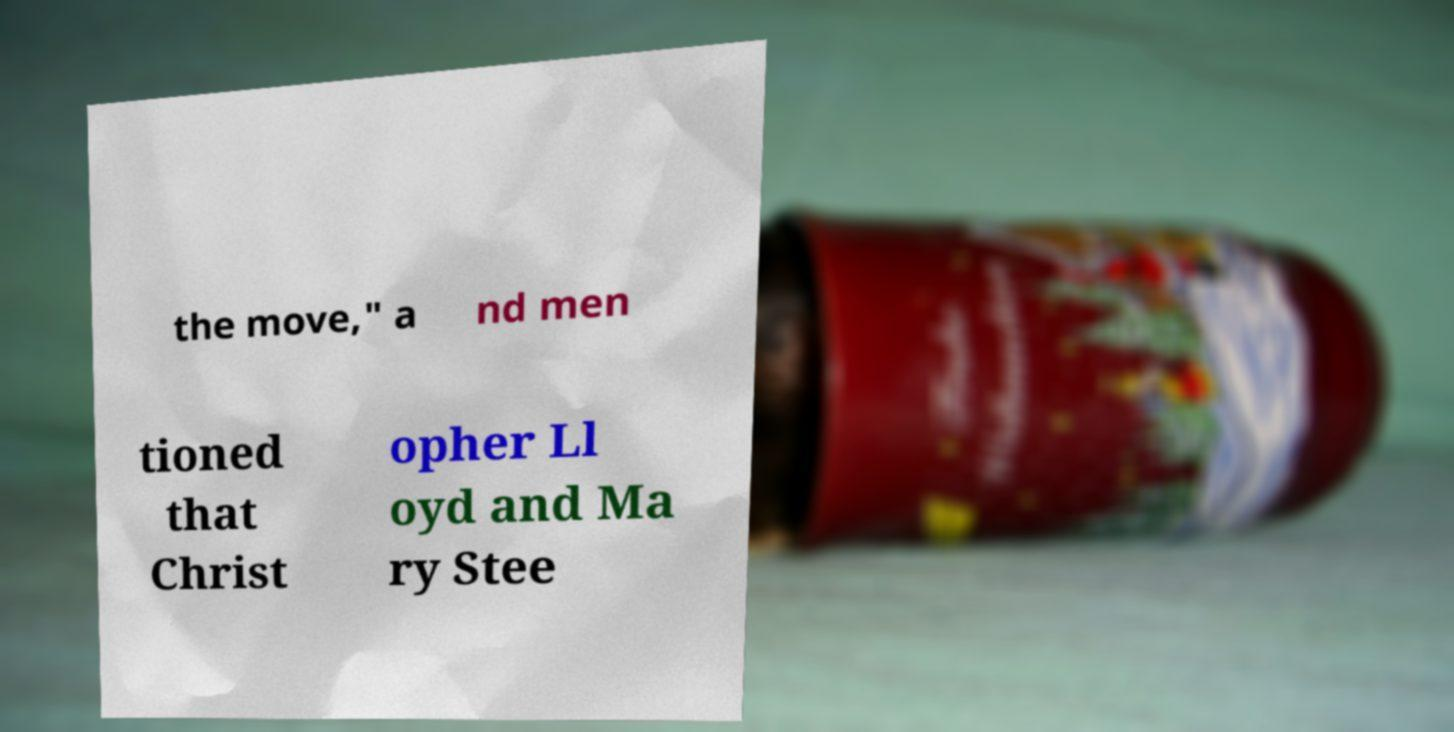There's text embedded in this image that I need extracted. Can you transcribe it verbatim? the move," a nd men tioned that Christ opher Ll oyd and Ma ry Stee 